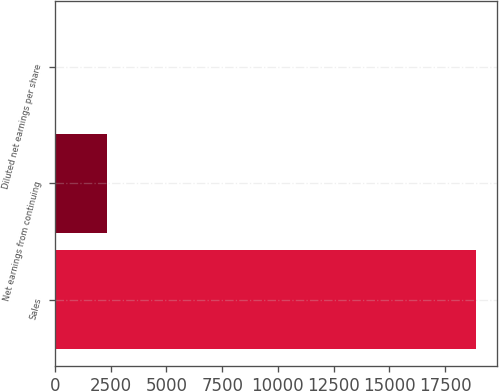Convert chart. <chart><loc_0><loc_0><loc_500><loc_500><bar_chart><fcel>Sales<fcel>Net earnings from continuing<fcel>Diluted net earnings per share<nl><fcel>18891.7<fcel>2322.6<fcel>3.27<nl></chart> 